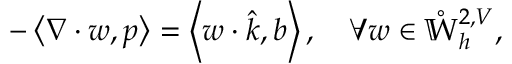Convert formula to latex. <formula><loc_0><loc_0><loc_500><loc_500>- \left \langle \nabla \cdot w , p \right \rangle = \left \langle w \cdot \hat { k } , b \right \rangle , \quad \forall w \in \mathring { \mathbb { W } } _ { h } ^ { 2 , V } ,</formula> 